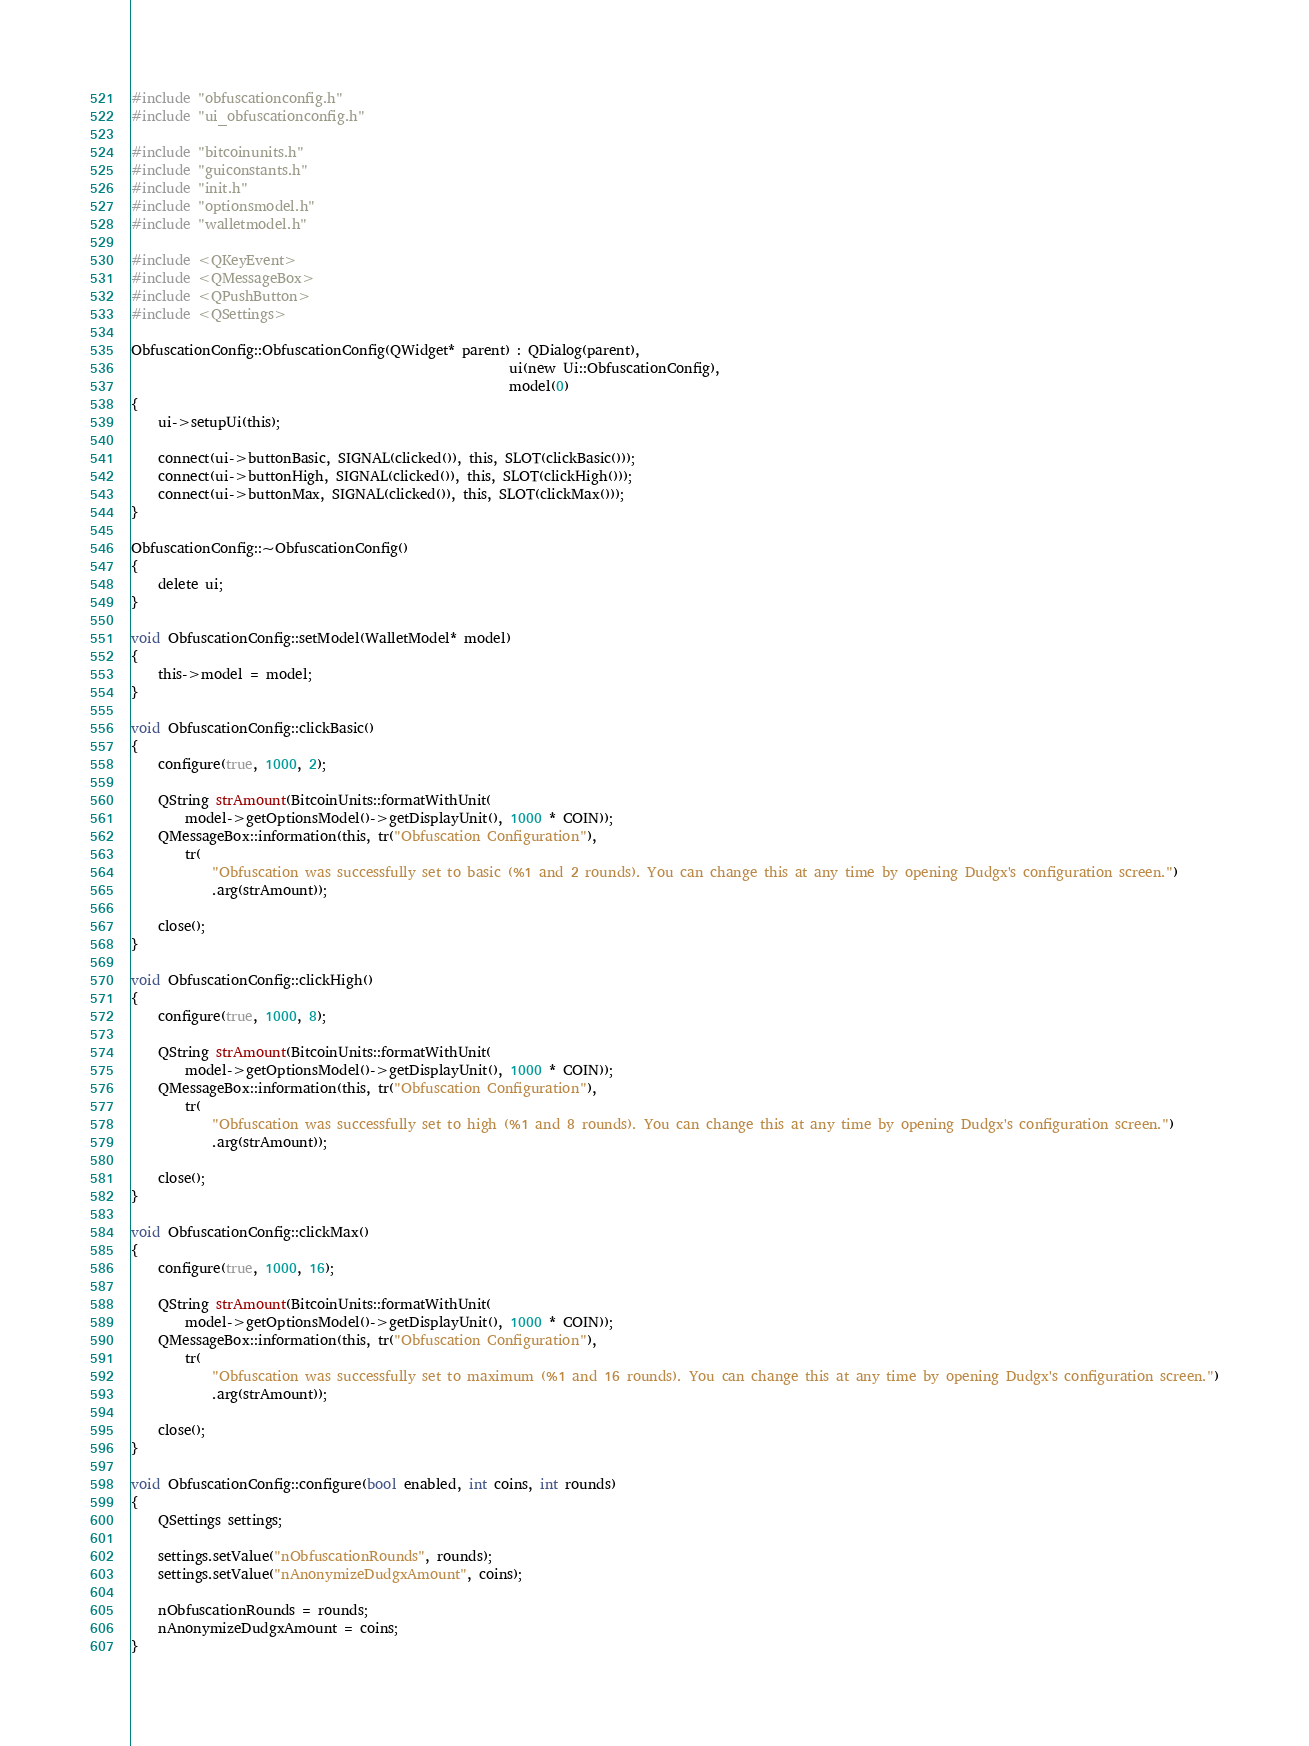Convert code to text. <code><loc_0><loc_0><loc_500><loc_500><_C++_>#include "obfuscationconfig.h"
#include "ui_obfuscationconfig.h"

#include "bitcoinunits.h"
#include "guiconstants.h"
#include "init.h"
#include "optionsmodel.h"
#include "walletmodel.h"

#include <QKeyEvent>
#include <QMessageBox>
#include <QPushButton>
#include <QSettings>

ObfuscationConfig::ObfuscationConfig(QWidget* parent) : QDialog(parent),
                                                        ui(new Ui::ObfuscationConfig),
                                                        model(0)
{
    ui->setupUi(this);

    connect(ui->buttonBasic, SIGNAL(clicked()), this, SLOT(clickBasic()));
    connect(ui->buttonHigh, SIGNAL(clicked()), this, SLOT(clickHigh()));
    connect(ui->buttonMax, SIGNAL(clicked()), this, SLOT(clickMax()));
}

ObfuscationConfig::~ObfuscationConfig()
{
    delete ui;
}

void ObfuscationConfig::setModel(WalletModel* model)
{
    this->model = model;
}

void ObfuscationConfig::clickBasic()
{
    configure(true, 1000, 2);

    QString strAmount(BitcoinUnits::formatWithUnit(
        model->getOptionsModel()->getDisplayUnit(), 1000 * COIN));
    QMessageBox::information(this, tr("Obfuscation Configuration"),
        tr(
            "Obfuscation was successfully set to basic (%1 and 2 rounds). You can change this at any time by opening Dudgx's configuration screen.")
            .arg(strAmount));

    close();
}

void ObfuscationConfig::clickHigh()
{
    configure(true, 1000, 8);

    QString strAmount(BitcoinUnits::formatWithUnit(
        model->getOptionsModel()->getDisplayUnit(), 1000 * COIN));
    QMessageBox::information(this, tr("Obfuscation Configuration"),
        tr(
            "Obfuscation was successfully set to high (%1 and 8 rounds). You can change this at any time by opening Dudgx's configuration screen.")
            .arg(strAmount));

    close();
}

void ObfuscationConfig::clickMax()
{
    configure(true, 1000, 16);

    QString strAmount(BitcoinUnits::formatWithUnit(
        model->getOptionsModel()->getDisplayUnit(), 1000 * COIN));
    QMessageBox::information(this, tr("Obfuscation Configuration"),
        tr(
            "Obfuscation was successfully set to maximum (%1 and 16 rounds). You can change this at any time by opening Dudgx's configuration screen.")
            .arg(strAmount));

    close();
}

void ObfuscationConfig::configure(bool enabled, int coins, int rounds)
{
    QSettings settings;

    settings.setValue("nObfuscationRounds", rounds);
    settings.setValue("nAnonymizeDudgxAmount", coins);

    nObfuscationRounds = rounds;
    nAnonymizeDudgxAmount = coins;
}
</code> 